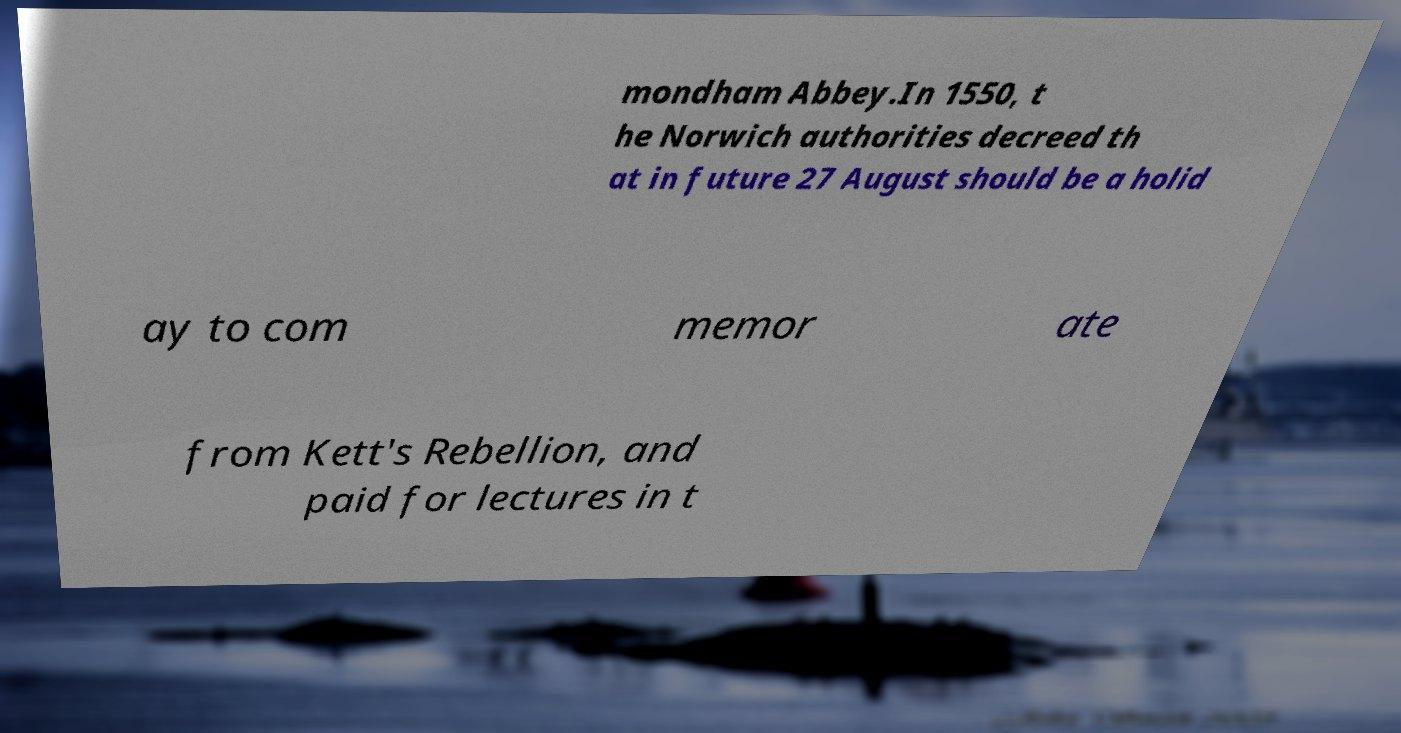I need the written content from this picture converted into text. Can you do that? mondham Abbey.In 1550, t he Norwich authorities decreed th at in future 27 August should be a holid ay to com memor ate from Kett's Rebellion, and paid for lectures in t 